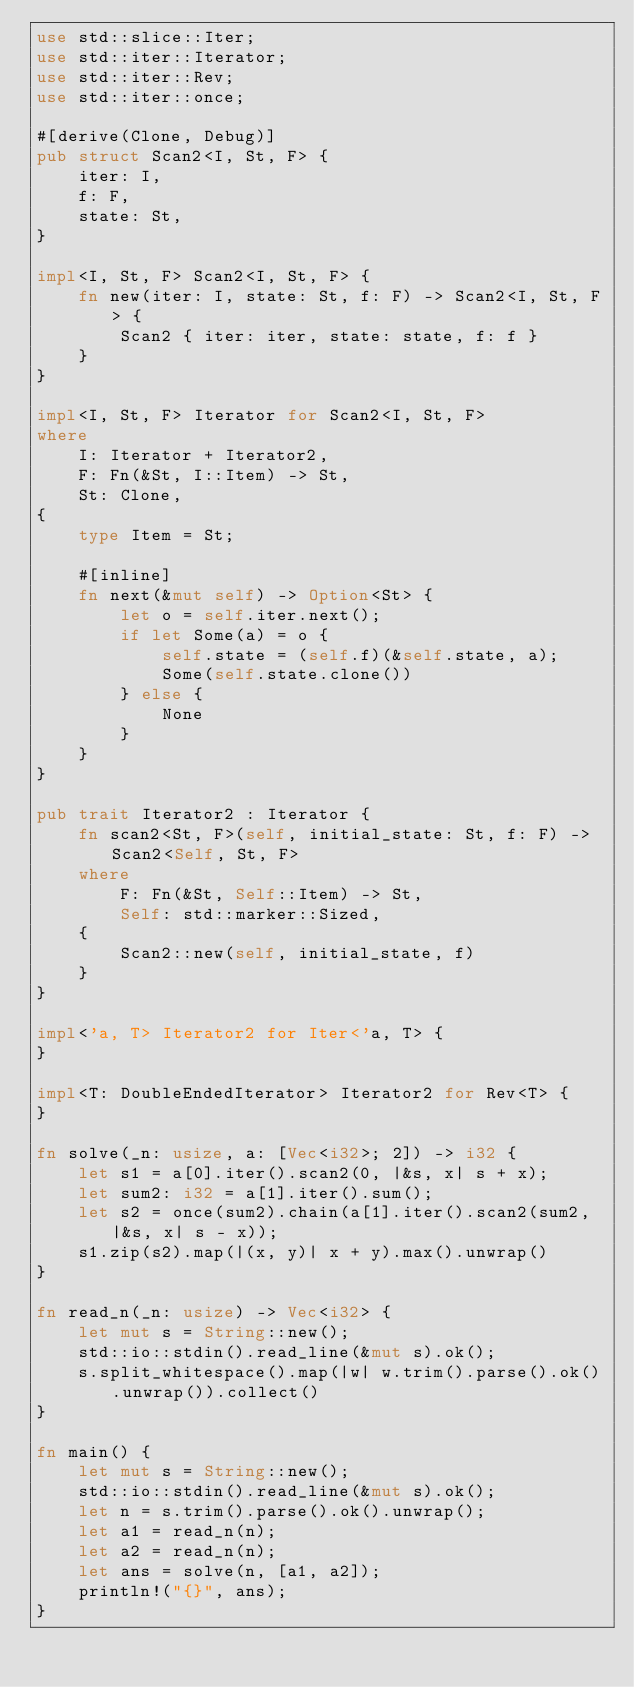<code> <loc_0><loc_0><loc_500><loc_500><_Rust_>use std::slice::Iter;
use std::iter::Iterator;
use std::iter::Rev;
use std::iter::once;

#[derive(Clone, Debug)]
pub struct Scan2<I, St, F> {
    iter: I,
    f: F,
    state: St,
}

impl<I, St, F> Scan2<I, St, F> {
    fn new(iter: I, state: St, f: F) -> Scan2<I, St, F> {
        Scan2 { iter: iter, state: state, f: f }
    }
}

impl<I, St, F> Iterator for Scan2<I, St, F>
where
    I: Iterator + Iterator2,
    F: Fn(&St, I::Item) -> St,
    St: Clone,
{
    type Item = St;

    #[inline]
    fn next(&mut self) -> Option<St> {
        let o = self.iter.next();
        if let Some(a) = o {
            self.state = (self.f)(&self.state, a);
            Some(self.state.clone())
        } else {
            None
        }
    }
}

pub trait Iterator2 : Iterator {
    fn scan2<St, F>(self, initial_state: St, f: F) -> Scan2<Self, St, F>
    where
        F: Fn(&St, Self::Item) -> St,
        Self: std::marker::Sized,
    {
        Scan2::new(self, initial_state, f)
    }
}

impl<'a, T> Iterator2 for Iter<'a, T> {
}

impl<T: DoubleEndedIterator> Iterator2 for Rev<T> {
}

fn solve(_n: usize, a: [Vec<i32>; 2]) -> i32 {
    let s1 = a[0].iter().scan2(0, |&s, x| s + x);
    let sum2: i32 = a[1].iter().sum();
    let s2 = once(sum2).chain(a[1].iter().scan2(sum2, |&s, x| s - x));
    s1.zip(s2).map(|(x, y)| x + y).max().unwrap()
}

fn read_n(_n: usize) -> Vec<i32> {
    let mut s = String::new();
    std::io::stdin().read_line(&mut s).ok();
    s.split_whitespace().map(|w| w.trim().parse().ok().unwrap()).collect()
}

fn main() {
    let mut s = String::new();
    std::io::stdin().read_line(&mut s).ok();
    let n = s.trim().parse().ok().unwrap();
    let a1 = read_n(n);
    let a2 = read_n(n);
    let ans = solve(n, [a1, a2]);
    println!("{}", ans);
}
</code> 